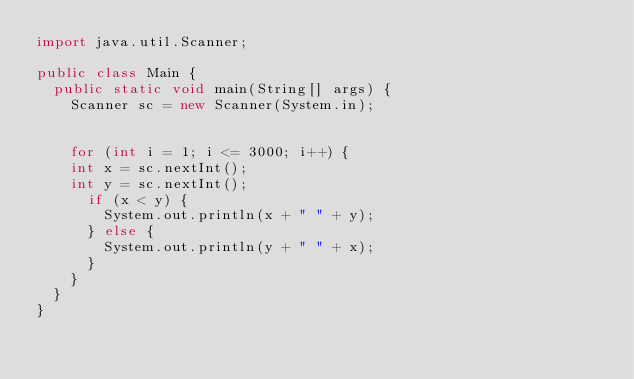Convert code to text. <code><loc_0><loc_0><loc_500><loc_500><_Java_>import java.util.Scanner;

public class Main {
	public static void main(String[] args) {
		Scanner sc = new Scanner(System.in);


		for (int i = 1; i <= 3000; i++) {
		int x = sc.nextInt();
		int y = sc.nextInt();
			if (x < y) {
				System.out.println(x + " " + y);
			} else {
				System.out.println(y + " " + x);
			}
		}
	}
}

</code> 